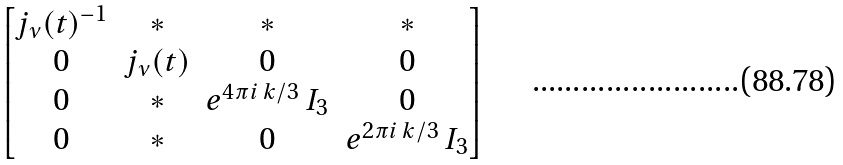Convert formula to latex. <formula><loc_0><loc_0><loc_500><loc_500>\begin{bmatrix} j _ { \nu } ( t ) ^ { - 1 } & * & * & * \\ 0 & j _ { \nu } ( t ) & 0 & 0 \\ 0 & * & e ^ { 4 \pi i \, k / 3 } \, I _ { 3 } & 0 \\ 0 & * & 0 & e ^ { 2 \pi i \, k / 3 } \, I _ { 3 } \end{bmatrix}</formula> 